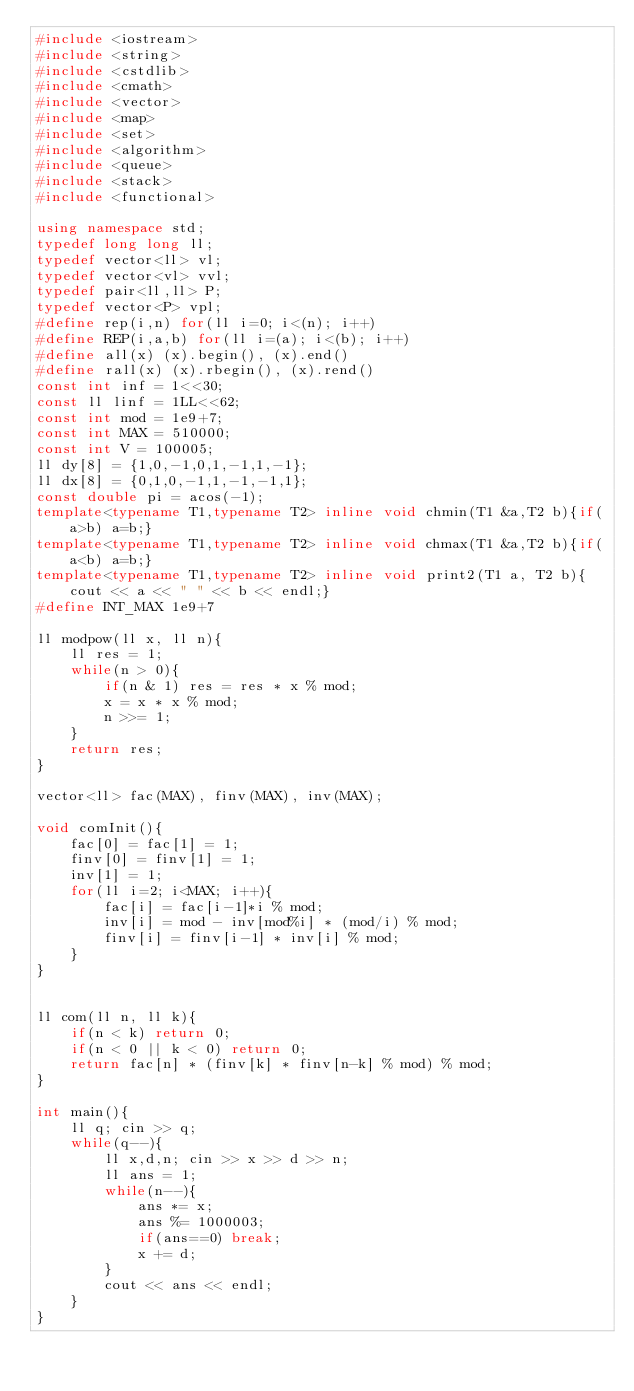<code> <loc_0><loc_0><loc_500><loc_500><_C++_>#include <iostream>
#include <string>
#include <cstdlib>
#include <cmath>
#include <vector>
#include <map>
#include <set>
#include <algorithm>
#include <queue>
#include <stack>
#include <functional>

using namespace std;
typedef long long ll;
typedef vector<ll> vl;
typedef vector<vl> vvl;
typedef pair<ll,ll> P;
typedef vector<P> vpl;
#define rep(i,n) for(ll i=0; i<(n); i++)
#define REP(i,a,b) for(ll i=(a); i<(b); i++)
#define all(x) (x).begin(), (x).end()
#define rall(x) (x).rbegin(), (x).rend()
const int inf = 1<<30;
const ll linf = 1LL<<62;
const int mod = 1e9+7;
const int MAX = 510000;
const int V = 100005;
ll dy[8] = {1,0,-1,0,1,-1,1,-1};
ll dx[8] = {0,1,0,-1,1,-1,-1,1};
const double pi = acos(-1);
template<typename T1,typename T2> inline void chmin(T1 &a,T2 b){if(a>b) a=b;}
template<typename T1,typename T2> inline void chmax(T1 &a,T2 b){if(a<b) a=b;}
template<typename T1,typename T2> inline void print2(T1 a, T2 b){cout << a << " " << b << endl;}
#define INT_MAX 1e9+7

ll modpow(ll x, ll n){
    ll res = 1;
    while(n > 0){
        if(n & 1) res = res * x % mod;
        x = x * x % mod;
        n >>= 1;
    }
    return res;
}

vector<ll> fac(MAX), finv(MAX), inv(MAX);

void comInit(){
    fac[0] = fac[1] = 1;
    finv[0] = finv[1] = 1;
    inv[1] = 1;
    for(ll i=2; i<MAX; i++){
        fac[i] = fac[i-1]*i % mod;
        inv[i] = mod - inv[mod%i] * (mod/i) % mod;
        finv[i] = finv[i-1] * inv[i] % mod;
    }
}


ll com(ll n, ll k){
    if(n < k) return 0;
    if(n < 0 || k < 0) return 0;
    return fac[n] * (finv[k] * finv[n-k] % mod) % mod;
}

int main(){
    ll q; cin >> q;
    while(q--){
        ll x,d,n; cin >> x >> d >> n;
        ll ans = 1;
        while(n--){
            ans *= x;
            ans %= 1000003;
            if(ans==0) break;
            x += d;
        }
        cout << ans << endl;
    }
}
</code> 